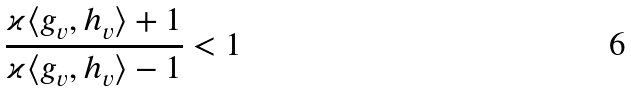<formula> <loc_0><loc_0><loc_500><loc_500>\frac { \varkappa \langle g _ { v } , h _ { v } \rangle + 1 } { \varkappa \langle g _ { v } , h _ { v } \rangle - 1 } < 1</formula> 